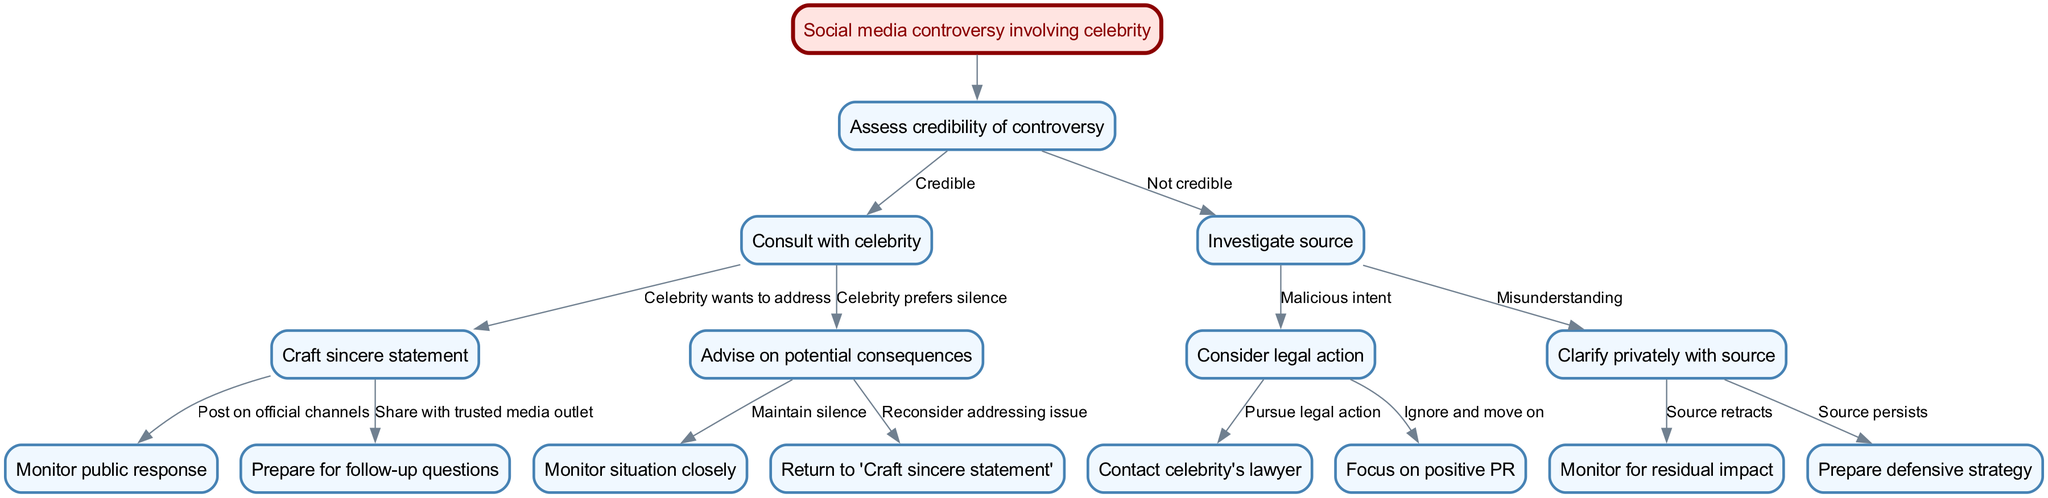What is the root node of the diagram? The root node is labeled as "Social media controversy involving celebrity". It serves as the starting point for the decision-making process depicted in the diagram.
Answer: Social media controversy involving celebrity How many main decisions are depicted in the diagram? The diagram contains one main decision categorized under the root node, leading to various options based on the credibility assessment of the controversy.
Answer: 1 What is the node that follows if the controversy is assessed as credible? If the controversy is credible, the next node is "Consult with celebrity", indicating the step to engage with the celebrity regarding the situation.
Answer: Consult with celebrity What is the edge leading from "Celebrity wants to address" to the next node? The edge leading from "Celebrity wants to address" denotes the action to "Craft sincere statement", indicating the celebrity's willingness to respond openly to the controversy.
Answer: Craft sincere statement If a source persists after being contacted for clarification, what is the next step in the decision tree? If the source persists after clarification, the next step is to "Prepare defensive strategy", indicating a proactive approach to manage the situation further.
Answer: Prepare defensive strategy What action is suggested if the controversy is determined to have malicious intent? The suggested action is to "Consider legal action", indicating a serious response to the finding of malicious intent in the controversy.
Answer: Consider legal action How does the tree proceed if the celebrity chooses to maintain silence? If the celebrity opts to maintain silence, the decision tree leads to the node "Monitor situation closely", suggesting a cautious monitoring of public reaction without direct engagement.
Answer: Monitor situation closely What happens if the source of the controversy retracts their statement? If the source retracts their statement, the action suggested is to "Monitor for residual impact", ensuring that any leftover effects of the controversy are observed.
Answer: Monitor for residual impact What is the final outcome if legal action is pursued? If legal action is pursued, the next step is to "Contact celebrity's lawyer", indicating the involvement of legal representation for the celebrity.
Answer: Contact celebrity's lawyer 